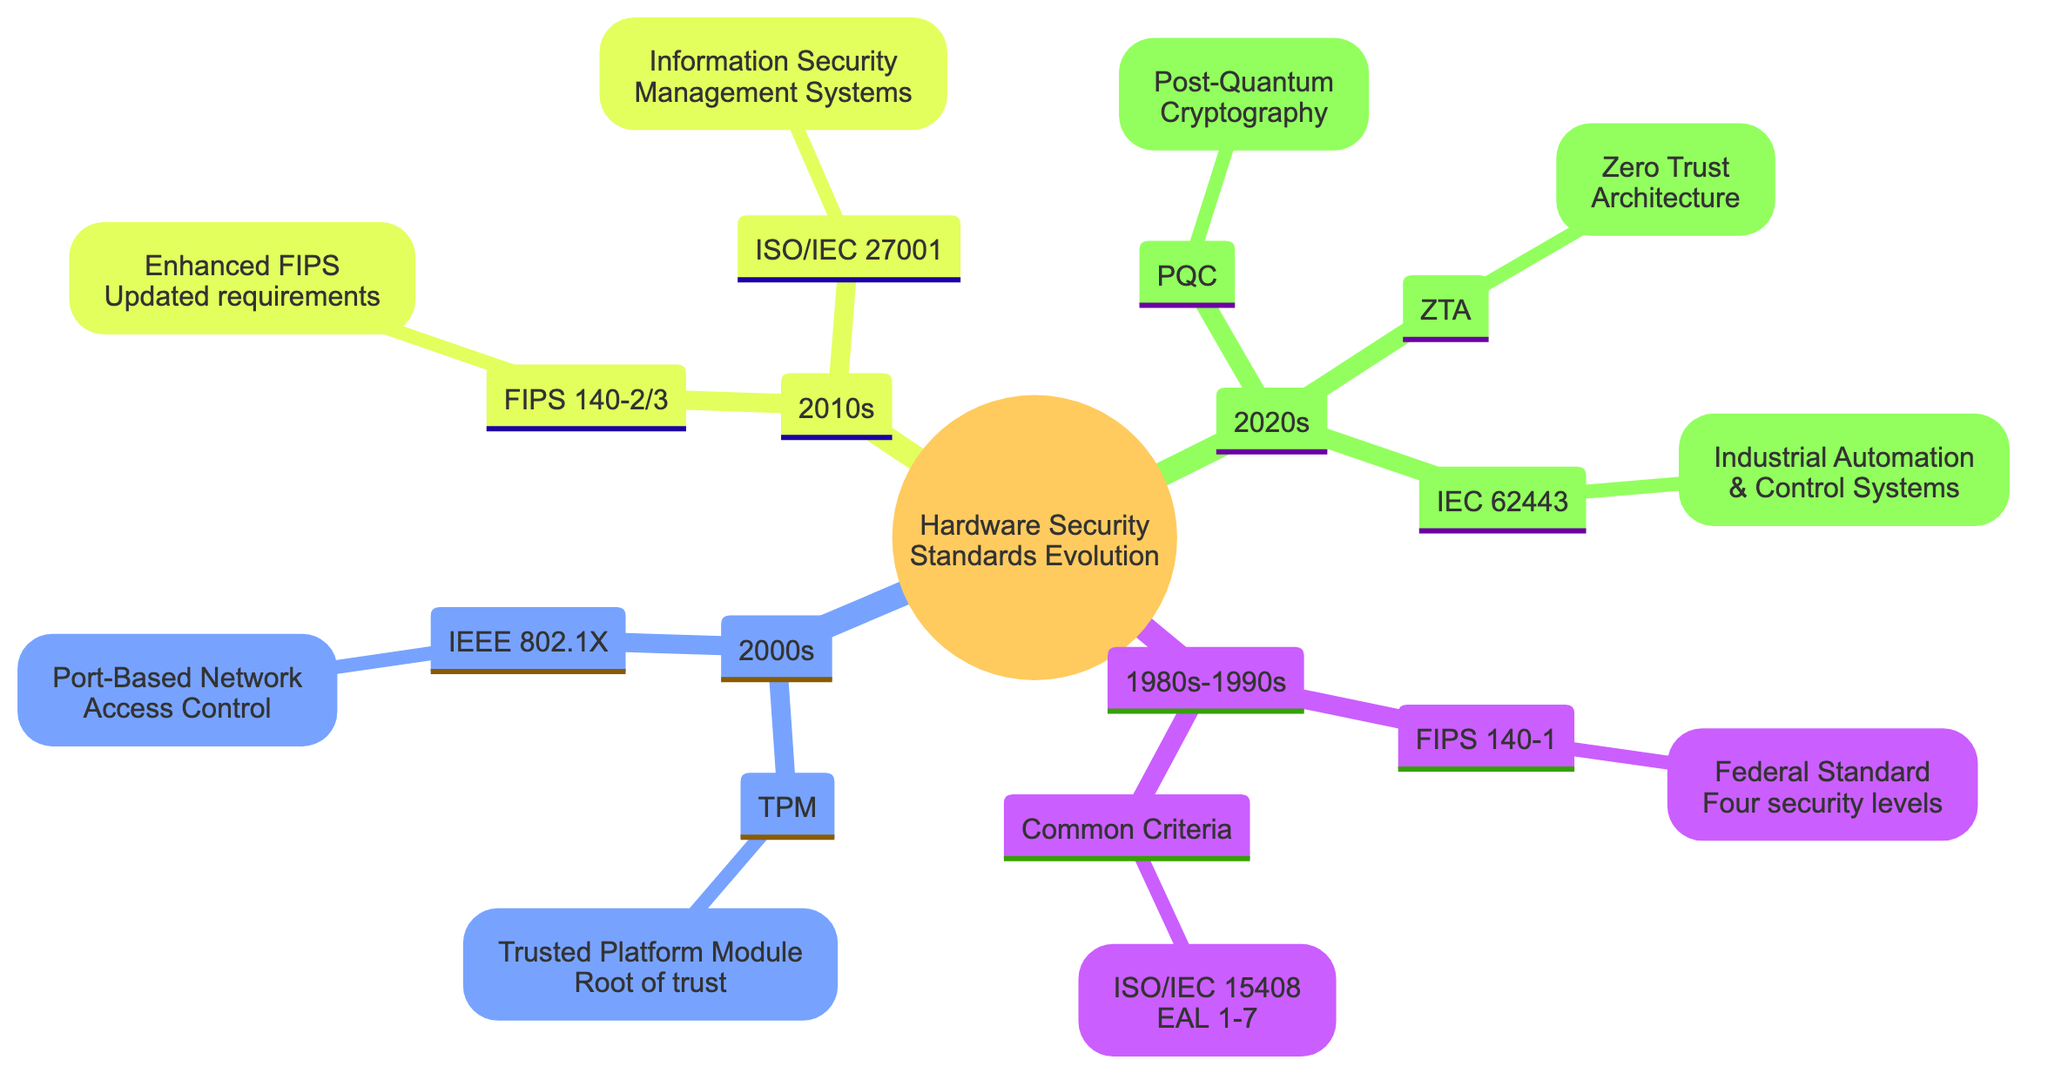What is the main standard from the 1980s-1990s? The main standard listed in the diagram for the 1980s-1990s is FIPS 140-1, which is represented prominently under that section.
Answer: FIPS 140-1 How many Evaluation Assurance Levels does the Common Criteria have? The diagram states that the Common Criteria has Evaluation Assurance Levels ranging from EAL 1 to EAL 7, indicating a total of seven levels.
Answer: 7 What protocol established a root of trust for computing devices in the 2000s? The diagram shows that the Trusted Platform Module (TPM) was established for this purpose, clearly linking the concept of a root of trust with this specific protocol in the 2000s section.
Answer: TPM What is a key feature of the Zero Trust Architecture? The diagram highlights "Minimal trust" as one of the key features of the Zero Trust Architecture, which is illustrated in the 2020s protocols section.
Answer: Minimal trust Which standard in the 2010s is focused on risk management? According to the diagram, the ISO/IEC 27001 standard, listed under the 2010s section, emphasizes a risk management approach in its features.
Answer: ISO/IEC 27001 What major development is associated with the 2020s in this concept map? The Post-Quantum Cryptography (PQC) is specifically mentioned as a major development in the 2020s subsection of the diagram.
Answer: Post-Quantum Cryptography How is the IEEE 802.1X primarily categorized? The diagram categorizes IEEE 802.1X as a "Port-Based Network Access Control" protocol developed in 2001, showing its specific focus in network security.
Answer: Port-Based Network Access Control Which standard has additional cryptographic algorithms compared to its predecessor? The diagram specifies that FIPS 140-2 and FIPS 140-3 are successors to FIPS 140-1 and include additional cryptographic algorithms, indicating an update in capabilities.
Answer: FIPS 140-2 and FIPS 140-3 